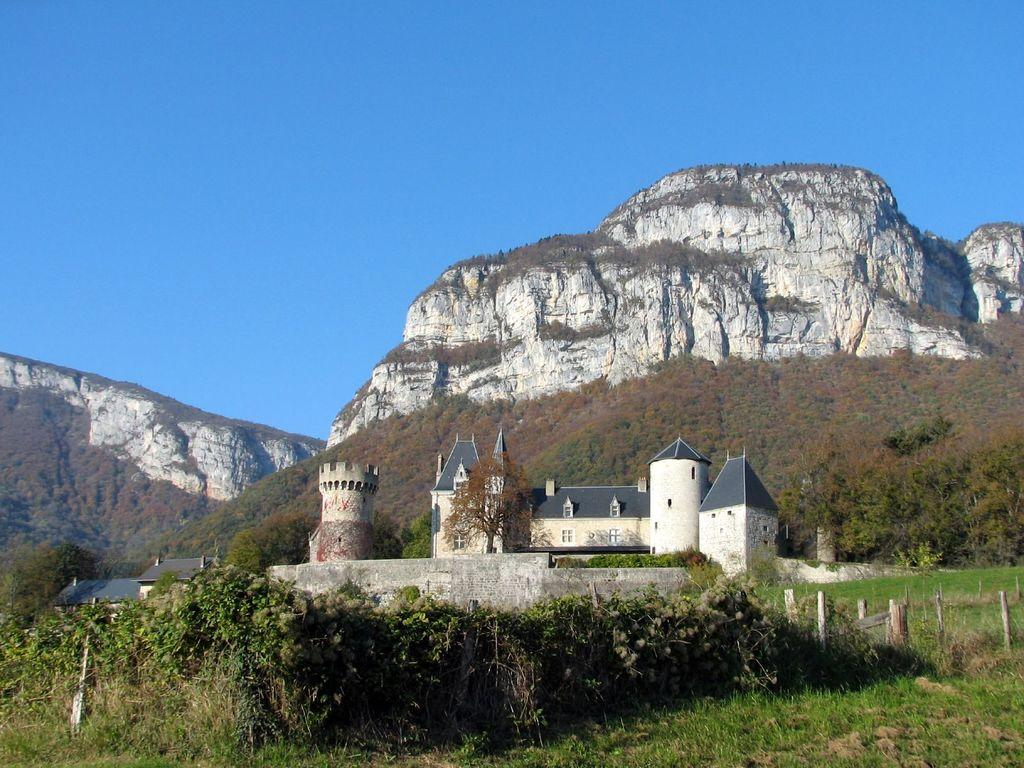What can be seen in the foreground of the picture? In the foreground of the picture, there are trees, plants, fencing, a building, and a castle. What is located in the middle of the picture? In the middle of the picture, there are mountains and trees. What is visible at the top of the picture? The sky is visible at the top of the picture. Can you see a net holding the mountains together in the image? There is no net present in the image; it features mountains, trees, and other elements in a natural landscape. What happens when the screw in the castle bursts in the image? There is no screw or bursting event involving the castle in the image; it is a static representation of a castle in the foreground. 